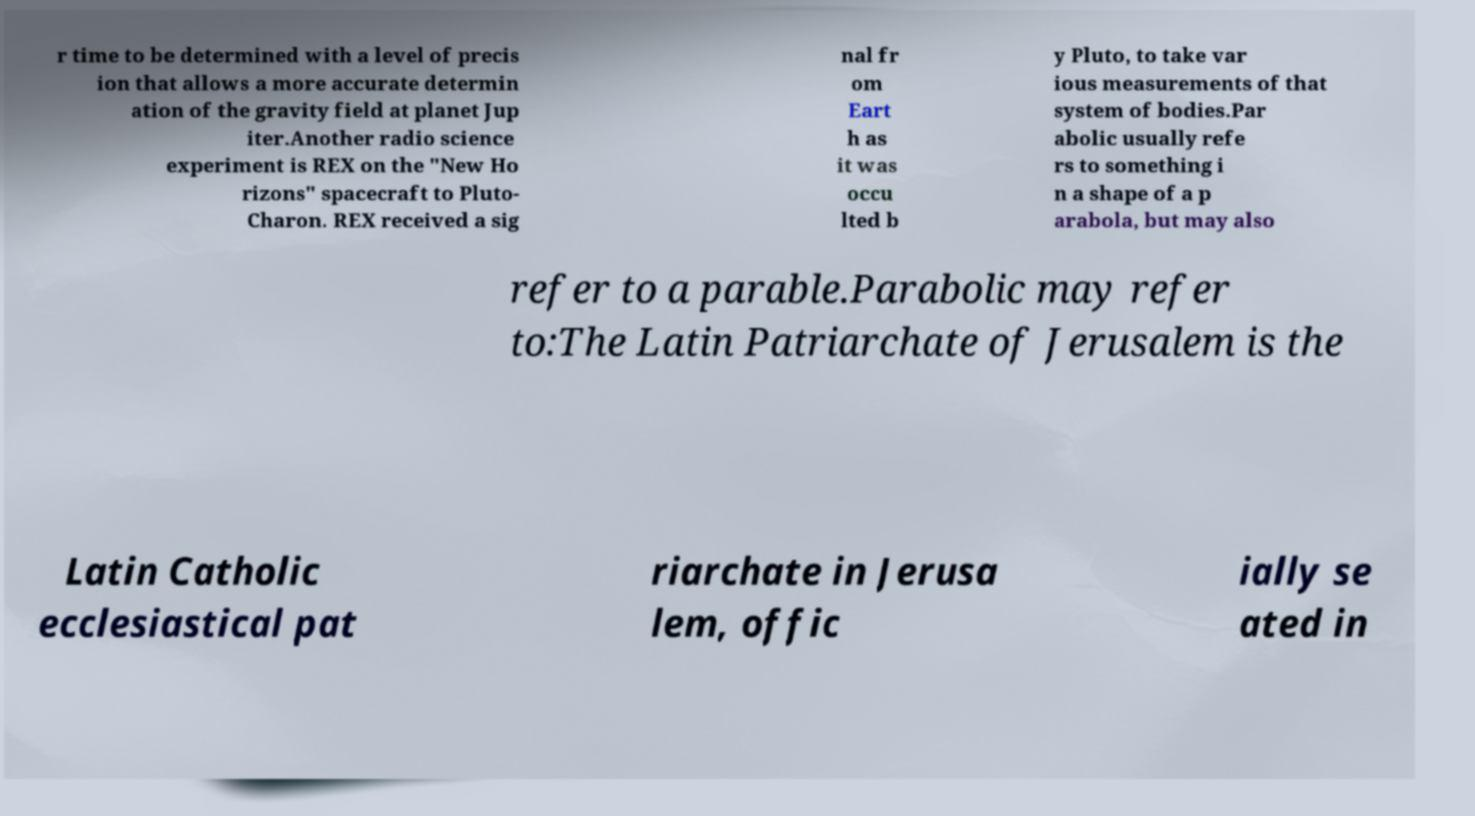Can you read and provide the text displayed in the image?This photo seems to have some interesting text. Can you extract and type it out for me? r time to be determined with a level of precis ion that allows a more accurate determin ation of the gravity field at planet Jup iter.Another radio science experiment is REX on the "New Ho rizons" spacecraft to Pluto- Charon. REX received a sig nal fr om Eart h as it was occu lted b y Pluto, to take var ious measurements of that system of bodies.Par abolic usually refe rs to something i n a shape of a p arabola, but may also refer to a parable.Parabolic may refer to:The Latin Patriarchate of Jerusalem is the Latin Catholic ecclesiastical pat riarchate in Jerusa lem, offic ially se ated in 